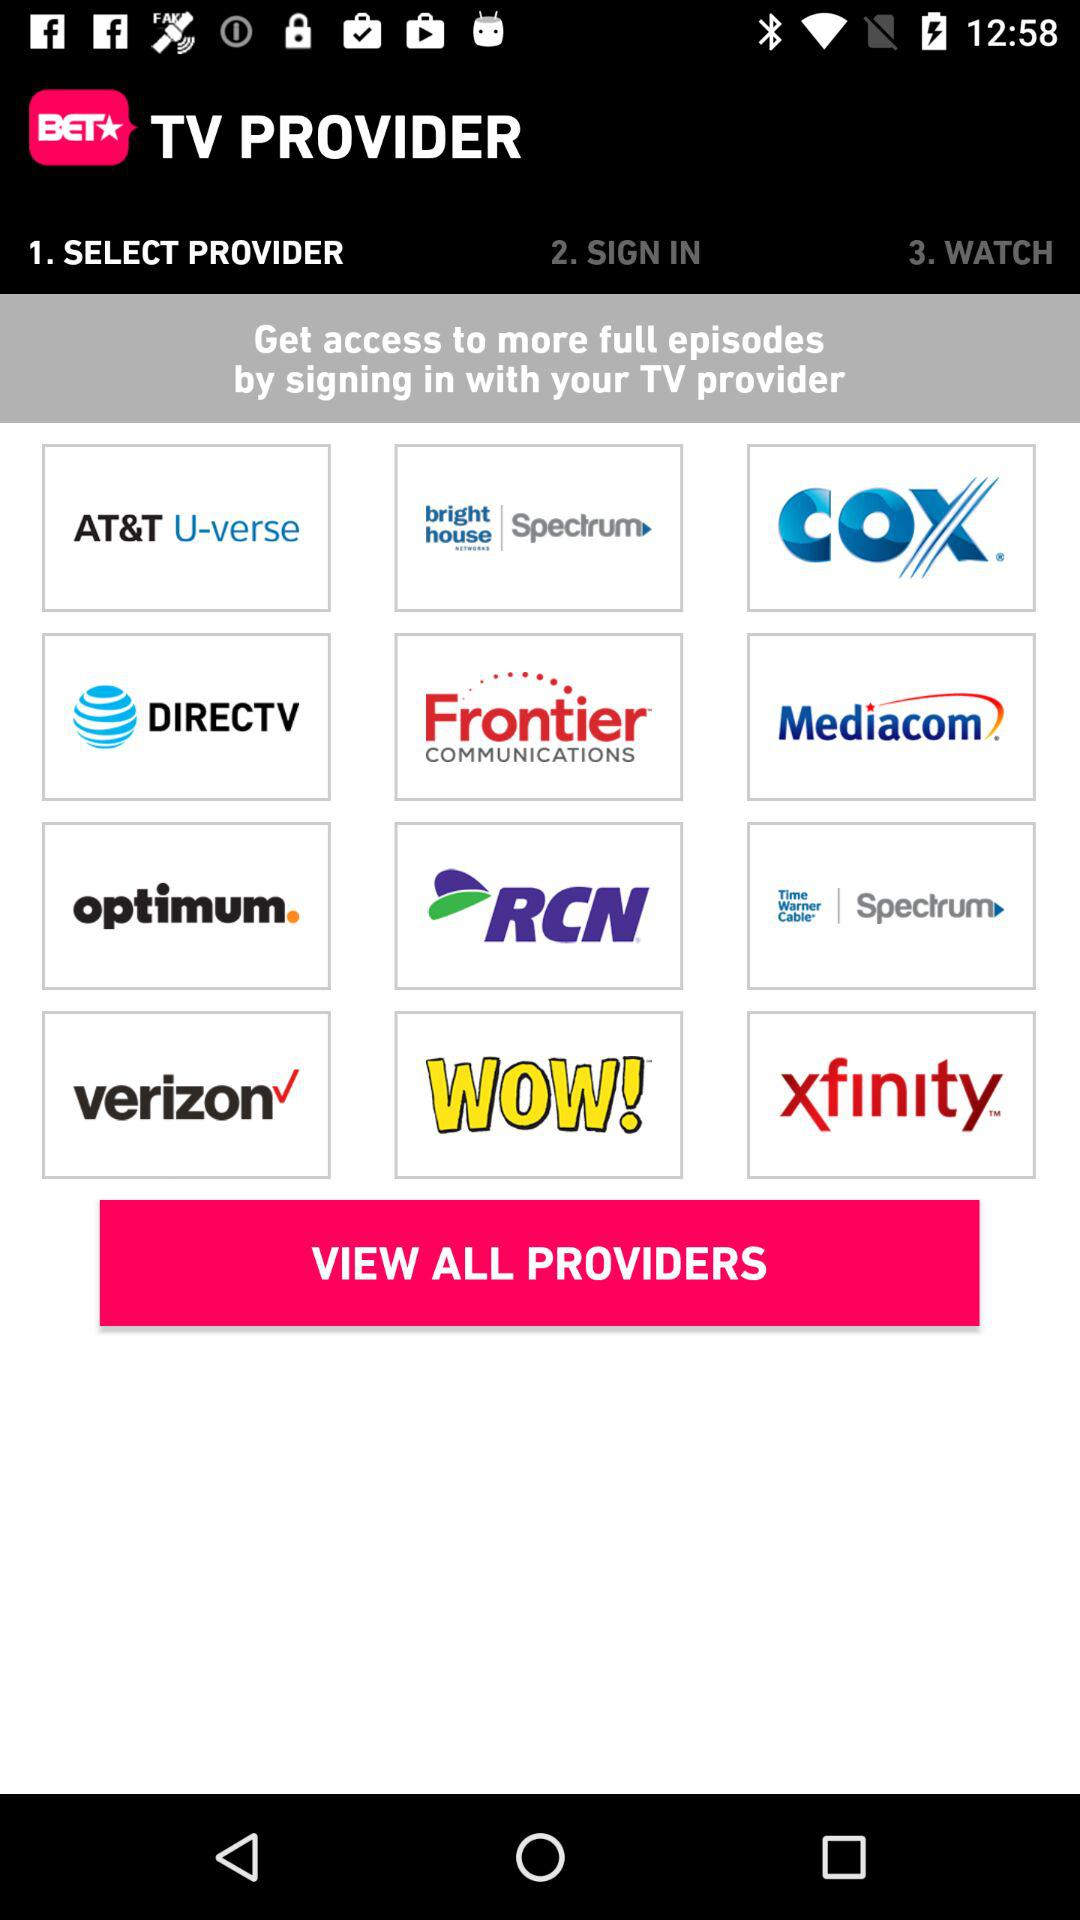What is required for signing in?
When the provided information is insufficient, respond with <no answer>. <no answer> 